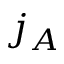<formula> <loc_0><loc_0><loc_500><loc_500>j _ { A }</formula> 